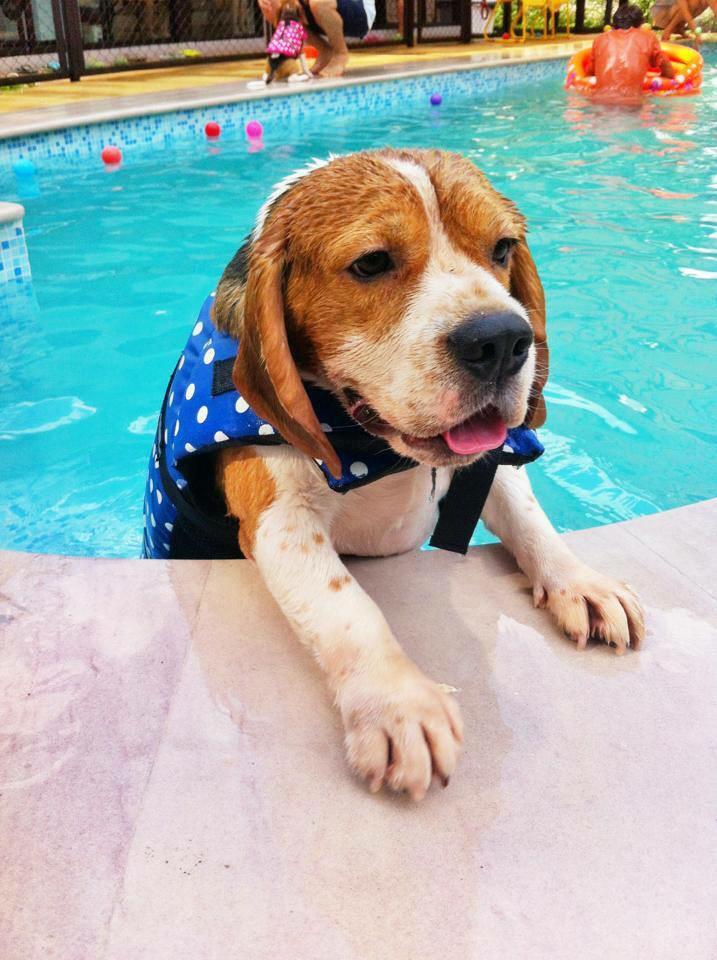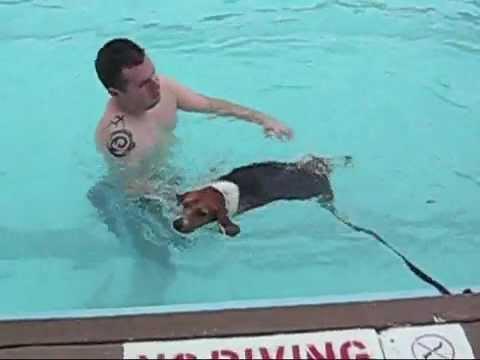The first image is the image on the left, the second image is the image on the right. Examine the images to the left and right. Is the description "a dog is swimming with a toy in its mouth" accurate? Answer yes or no. No. The first image is the image on the left, the second image is the image on the right. Given the left and right images, does the statement "The dog on the right image has its head under water." hold true? Answer yes or no. No. 